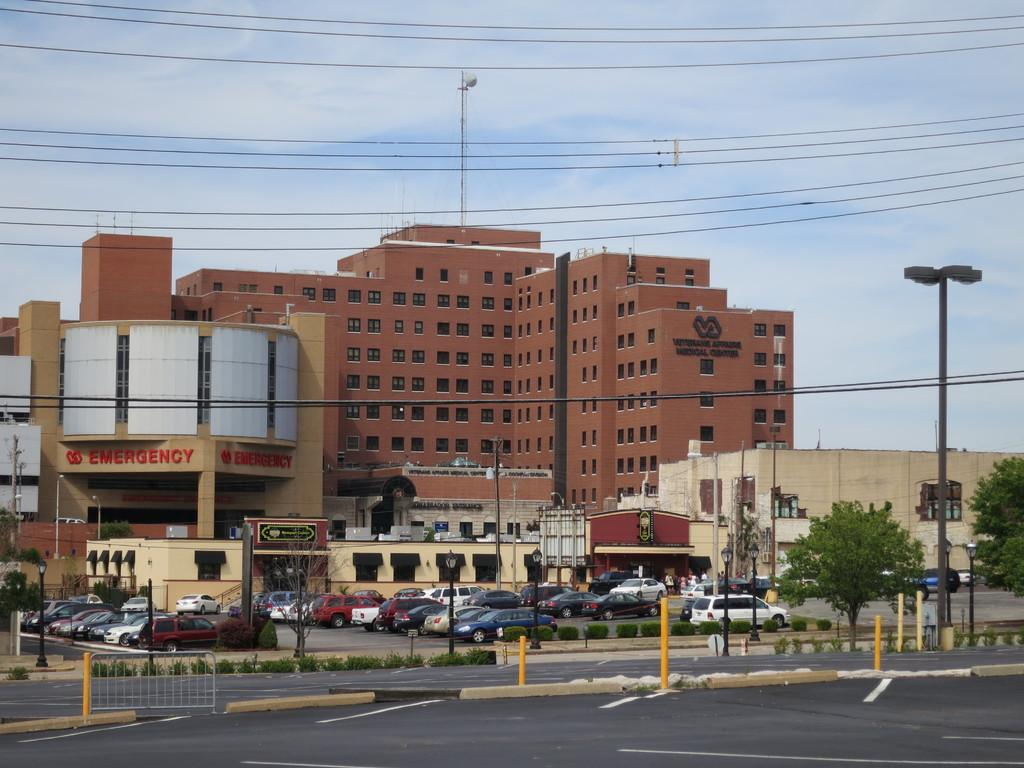What type of structures can be seen in the background of the image? There are buildings in the background of the image. What is on the road in front of the buildings? There are cars on the road in front of the buildings. What type of vegetation is on the right side of the image? Trees are present on the right side of the image. What is visible in the sky in the image? The sky is visible in the image, and clouds are present in the sky. How many pigs are jumping in the pocket in the image? There are no pigs or pockets present in the image. What type of twist can be seen in the image? There is no twist present in the image. 